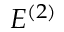Convert formula to latex. <formula><loc_0><loc_0><loc_500><loc_500>E ^ { ( 2 ) }</formula> 